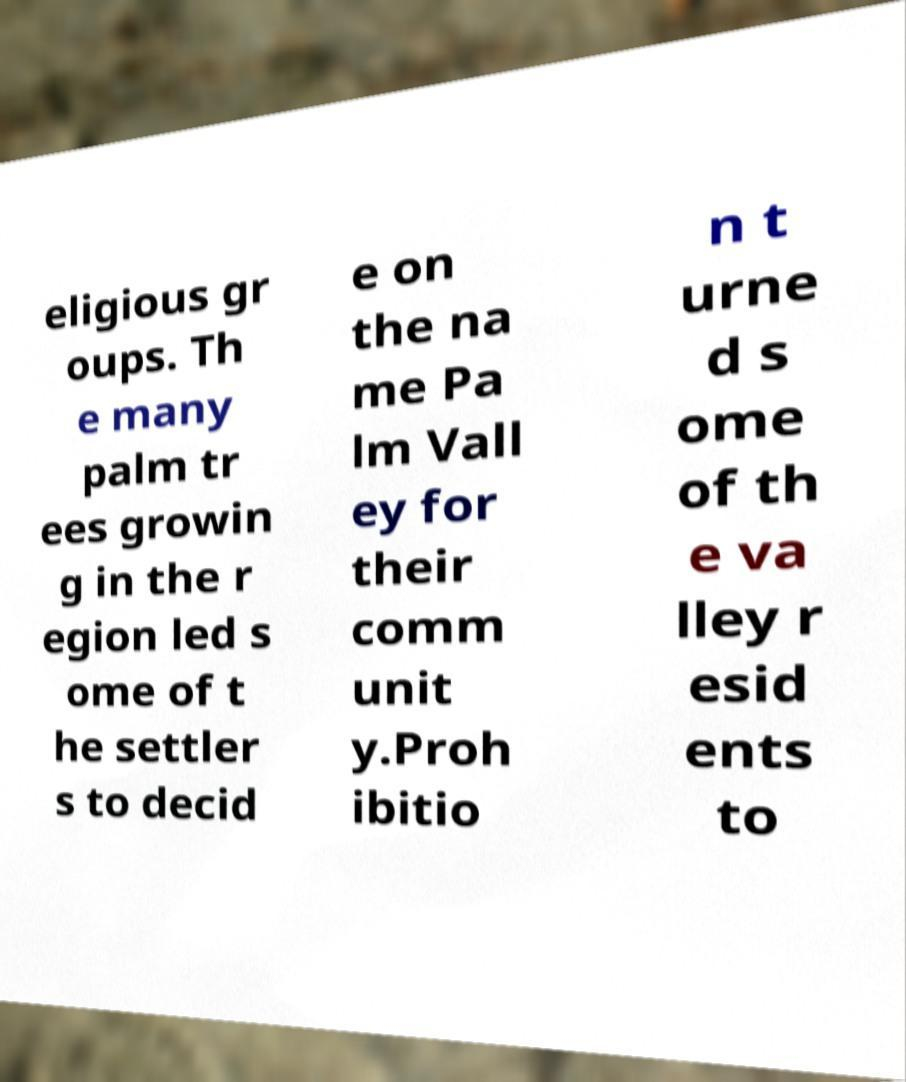Can you accurately transcribe the text from the provided image for me? eligious gr oups. Th e many palm tr ees growin g in the r egion led s ome of t he settler s to decid e on the na me Pa lm Vall ey for their comm unit y.Proh ibitio n t urne d s ome of th e va lley r esid ents to 